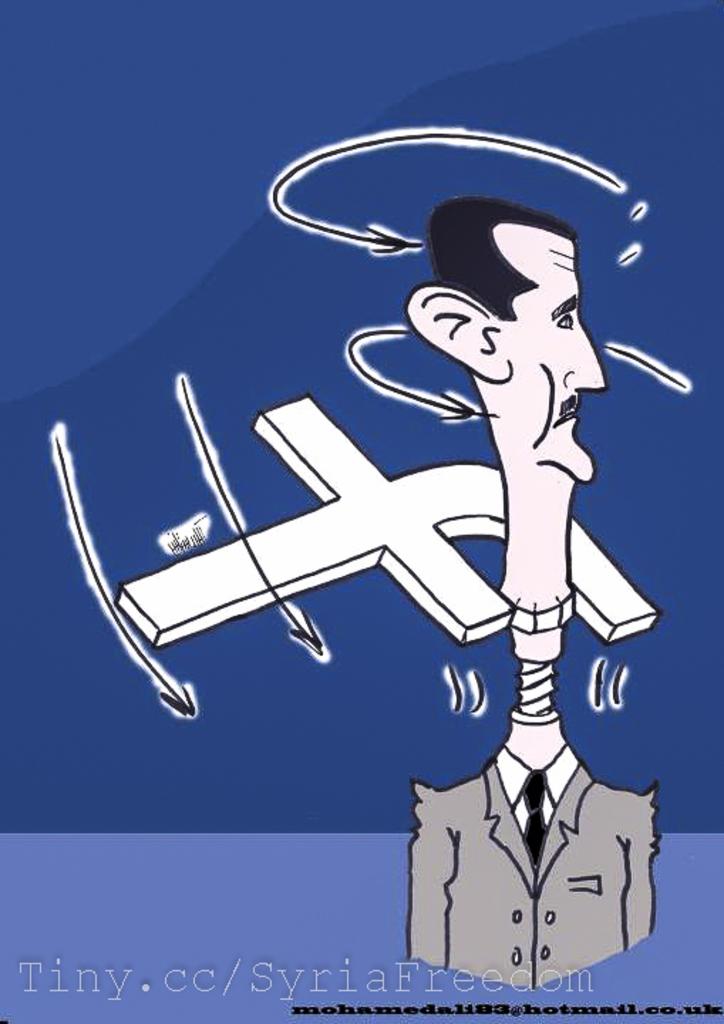What website is being advertised at the bottom?
Offer a terse response. Tiny.cc/syriafreedom. 